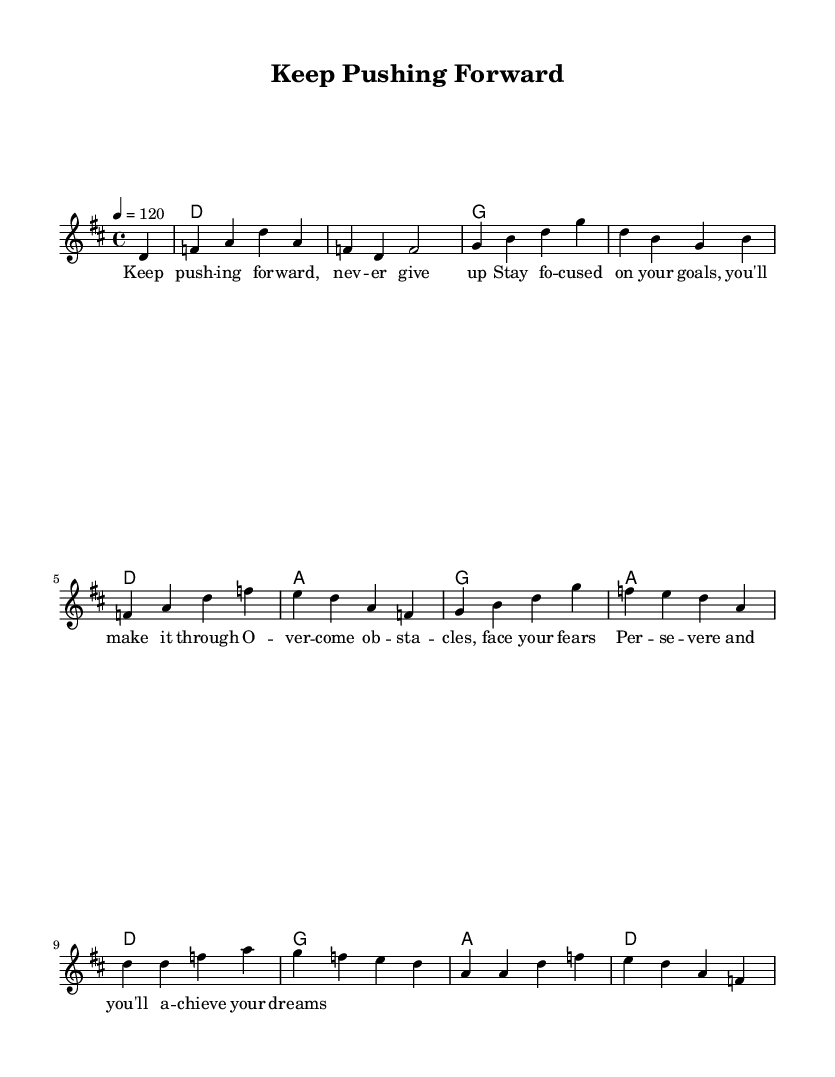What is the key signature of this music? The key signature is D major, which has two sharps: F sharp and C sharp.
Answer: D major What is the time signature of this music? The time signature is indicated as 4/4, meaning there are four beats in each measure and the quarter note receives one beat.
Answer: 4/4 What is the tempo marking in this piece? The tempo marking is set to a quarter note equals 120 beats per minute, which indicates the speed of the music.
Answer: 120 How many measures are in the melody? By counting the measures indicated in the melody section of the music, we find that there are 12 measures.
Answer: 12 What is the main theme of the lyrics? The lyrics focus on perseverance and determination, encouraging the listener to keep pushing forward and overcome obstacles.
Answer: Perseverance Which chord follows the first melody note? The first melody note after the pickup is D, and it is paired with a silent measure before the D major chord comes in.
Answer: D How many times does the G chord appear in the harmony section? In the harmony section, the G chord occurs three times across varying measures.
Answer: 3 